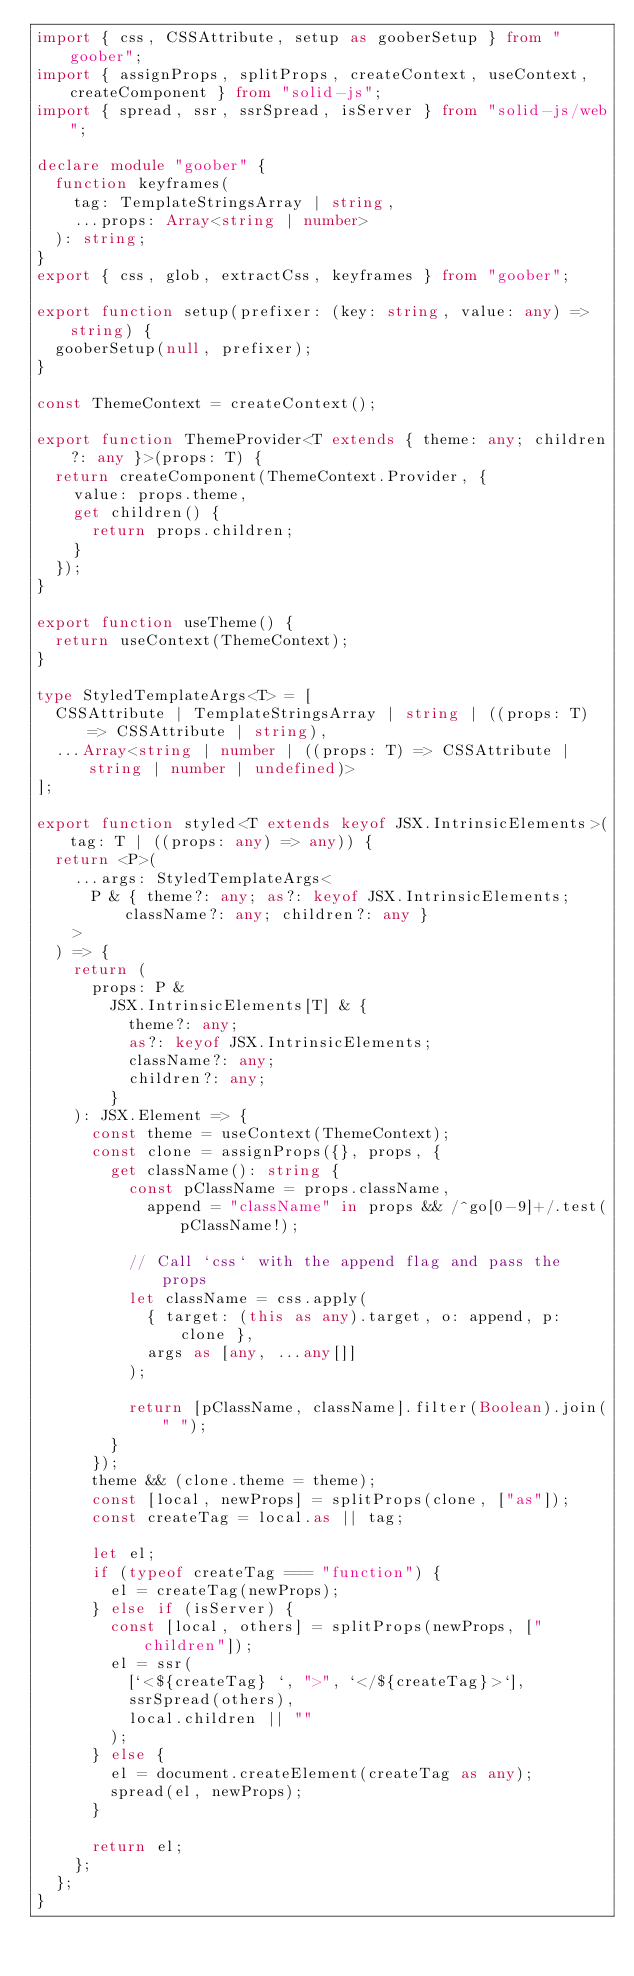<code> <loc_0><loc_0><loc_500><loc_500><_TypeScript_>import { css, CSSAttribute, setup as gooberSetup } from "goober";
import { assignProps, splitProps, createContext, useContext, createComponent } from "solid-js";
import { spread, ssr, ssrSpread, isServer } from "solid-js/web";

declare module "goober" {
  function keyframes(
    tag: TemplateStringsArray | string,
    ...props: Array<string | number>
  ): string;
}
export { css, glob, extractCss, keyframes } from "goober";

export function setup(prefixer: (key: string, value: any) => string) {
  gooberSetup(null, prefixer);
}

const ThemeContext = createContext();

export function ThemeProvider<T extends { theme: any; children?: any }>(props: T) {
  return createComponent(ThemeContext.Provider, {
    value: props.theme,
    get children() {
      return props.children;
    }
  });
}

export function useTheme() {
  return useContext(ThemeContext);
}

type StyledTemplateArgs<T> = [
  CSSAttribute | TemplateStringsArray | string | ((props: T) => CSSAttribute | string),
  ...Array<string | number | ((props: T) => CSSAttribute | string | number | undefined)>
];

export function styled<T extends keyof JSX.IntrinsicElements>(tag: T | ((props: any) => any)) {
  return <P>(
    ...args: StyledTemplateArgs<
      P & { theme?: any; as?: keyof JSX.IntrinsicElements; className?: any; children?: any }
    >
  ) => {
    return (
      props: P &
        JSX.IntrinsicElements[T] & {
          theme?: any;
          as?: keyof JSX.IntrinsicElements;
          className?: any;
          children?: any;
        }
    ): JSX.Element => {
      const theme = useContext(ThemeContext);
      const clone = assignProps({}, props, {
        get className(): string {
          const pClassName = props.className,
            append = "className" in props && /^go[0-9]+/.test(pClassName!);

          // Call `css` with the append flag and pass the props
          let className = css.apply(
            { target: (this as any).target, o: append, p: clone },
            args as [any, ...any[]]
          );

          return [pClassName, className].filter(Boolean).join(" ");
        }
      });
      theme && (clone.theme = theme);
      const [local, newProps] = splitProps(clone, ["as"]);
      const createTag = local.as || tag;

      let el;
      if (typeof createTag === "function") {
        el = createTag(newProps);
      } else if (isServer) {
        const [local, others] = splitProps(newProps, ["children"]);
        el = ssr(
          [`<${createTag} `, ">", `</${createTag}>`],
          ssrSpread(others),
          local.children || ""
        );
      } else {
        el = document.createElement(createTag as any);
        spread(el, newProps);
      }

      return el;
    };
  };
}
</code> 